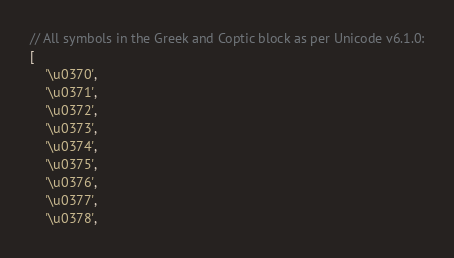<code> <loc_0><loc_0><loc_500><loc_500><_JavaScript_>// All symbols in the Greek and Coptic block as per Unicode v6.1.0:
[
	'\u0370',
	'\u0371',
	'\u0372',
	'\u0373',
	'\u0374',
	'\u0375',
	'\u0376',
	'\u0377',
	'\u0378',</code> 